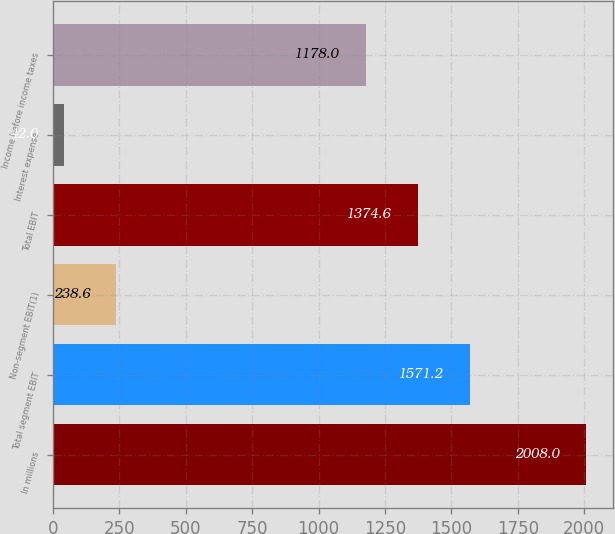<chart> <loc_0><loc_0><loc_500><loc_500><bar_chart><fcel>In millions<fcel>Total segment EBIT<fcel>Non-segment EBIT(1)<fcel>Total EBIT<fcel>Interest expense<fcel>Income before income taxes<nl><fcel>2008<fcel>1571.2<fcel>238.6<fcel>1374.6<fcel>42<fcel>1178<nl></chart> 